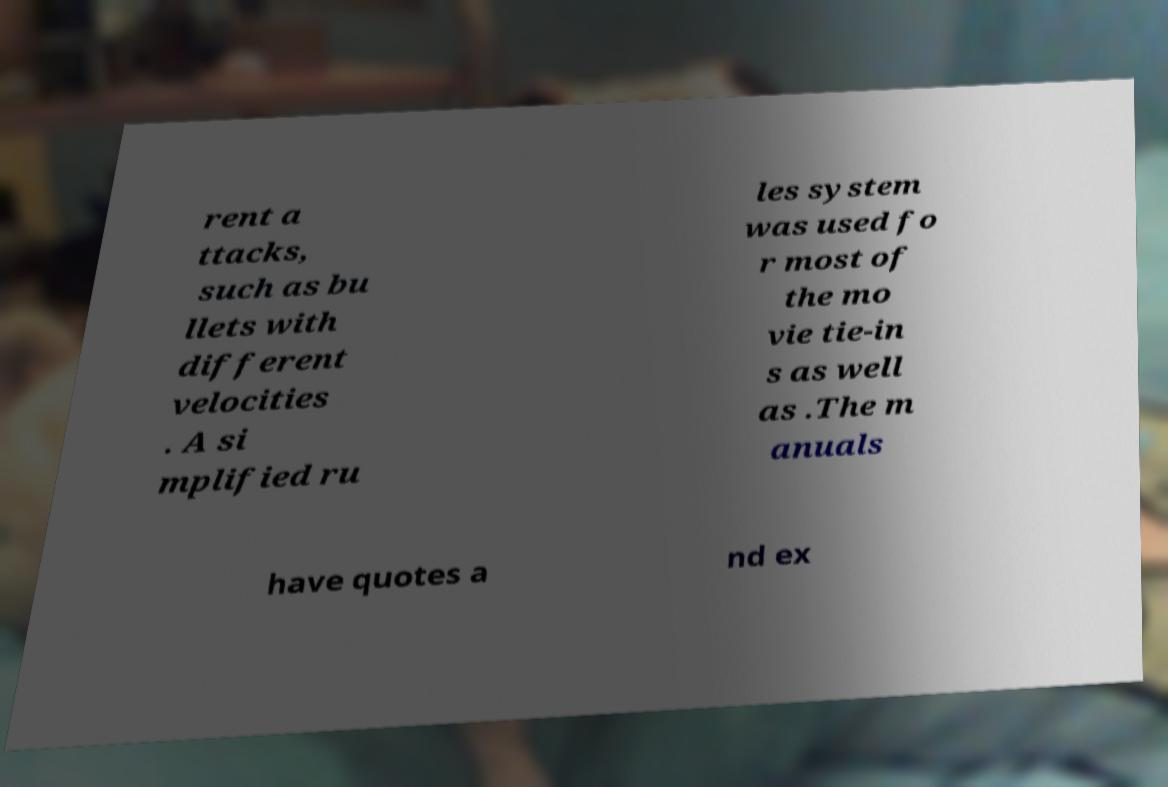There's text embedded in this image that I need extracted. Can you transcribe it verbatim? rent a ttacks, such as bu llets with different velocities . A si mplified ru les system was used fo r most of the mo vie tie-in s as well as .The m anuals have quotes a nd ex 